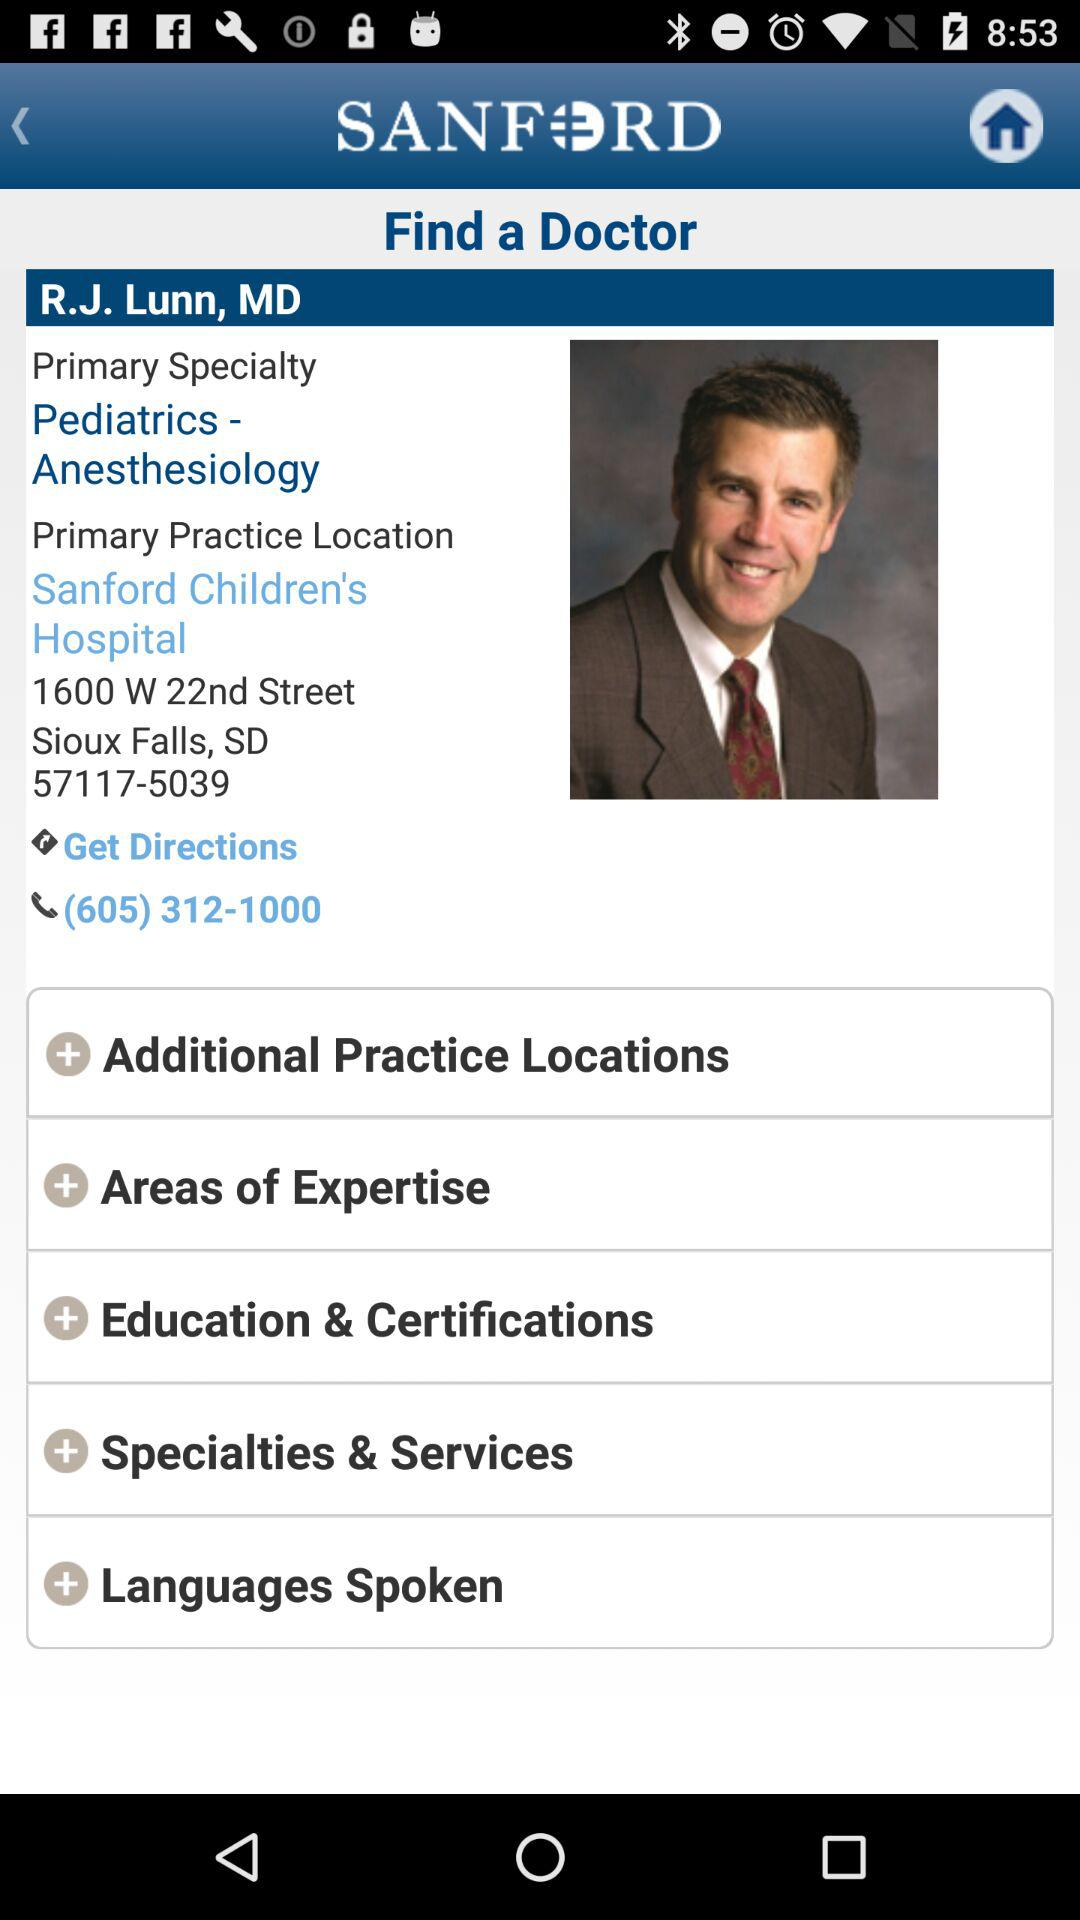What is the contact number? The contact number is (605) 312-1000. 